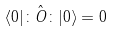Convert formula to latex. <formula><loc_0><loc_0><loc_500><loc_500>\langle 0 | \colon \hat { O } \colon | 0 \rangle = 0</formula> 